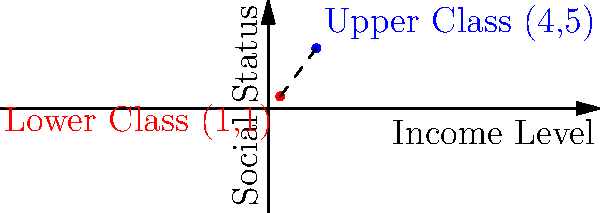In a sociological study on income inequality, two socioeconomic classes are represented as points on a coordinate plane. The lower class is positioned at (1,1), while the upper class is at (4,5). Calculate the distance between these two classes, representing the socioeconomic gap. How might this quantitative measure inform discussions about social mobility and class differences? To calculate the distance between two points on a coordinate plane, we use the distance formula derived from the Pythagorean theorem:

$$d = \sqrt{(x_2 - x_1)^2 + (y_2 - y_1)^2}$$

Where $(x_1, y_1)$ represents the coordinates of the first point (lower class) and $(x_2, y_2)$ represents the coordinates of the second point (upper class).

Step 1: Identify the coordinates
Lower class: $(x_1, y_1) = (1, 1)$
Upper class: $(x_2, y_2) = (4, 5)$

Step 2: Plug the values into the distance formula
$$d = \sqrt{(4 - 1)^2 + (5 - 1)^2}$$

Step 3: Simplify the expressions inside the parentheses
$$d = \sqrt{3^2 + 4^2}$$

Step 4: Calculate the squares
$$d = \sqrt{9 + 16}$$

Step 5: Add the values under the square root
$$d = \sqrt{25}$$

Step 6: Simplify the square root
$$d = 5$$

The distance between the two classes is 5 units on this coordinate plane.

This quantitative measure can inform discussions about social mobility and class differences by:
1. Providing a numerical representation of the socioeconomic gap
2. Allowing for comparisons between different societies or time periods
3. Serving as a basis for analyzing factors that contribute to class separation
4. Highlighting the multidimensional nature of social class (income and status)
5. Encouraging debates on policies to reduce this gap and promote social mobility
Answer: 5 units 